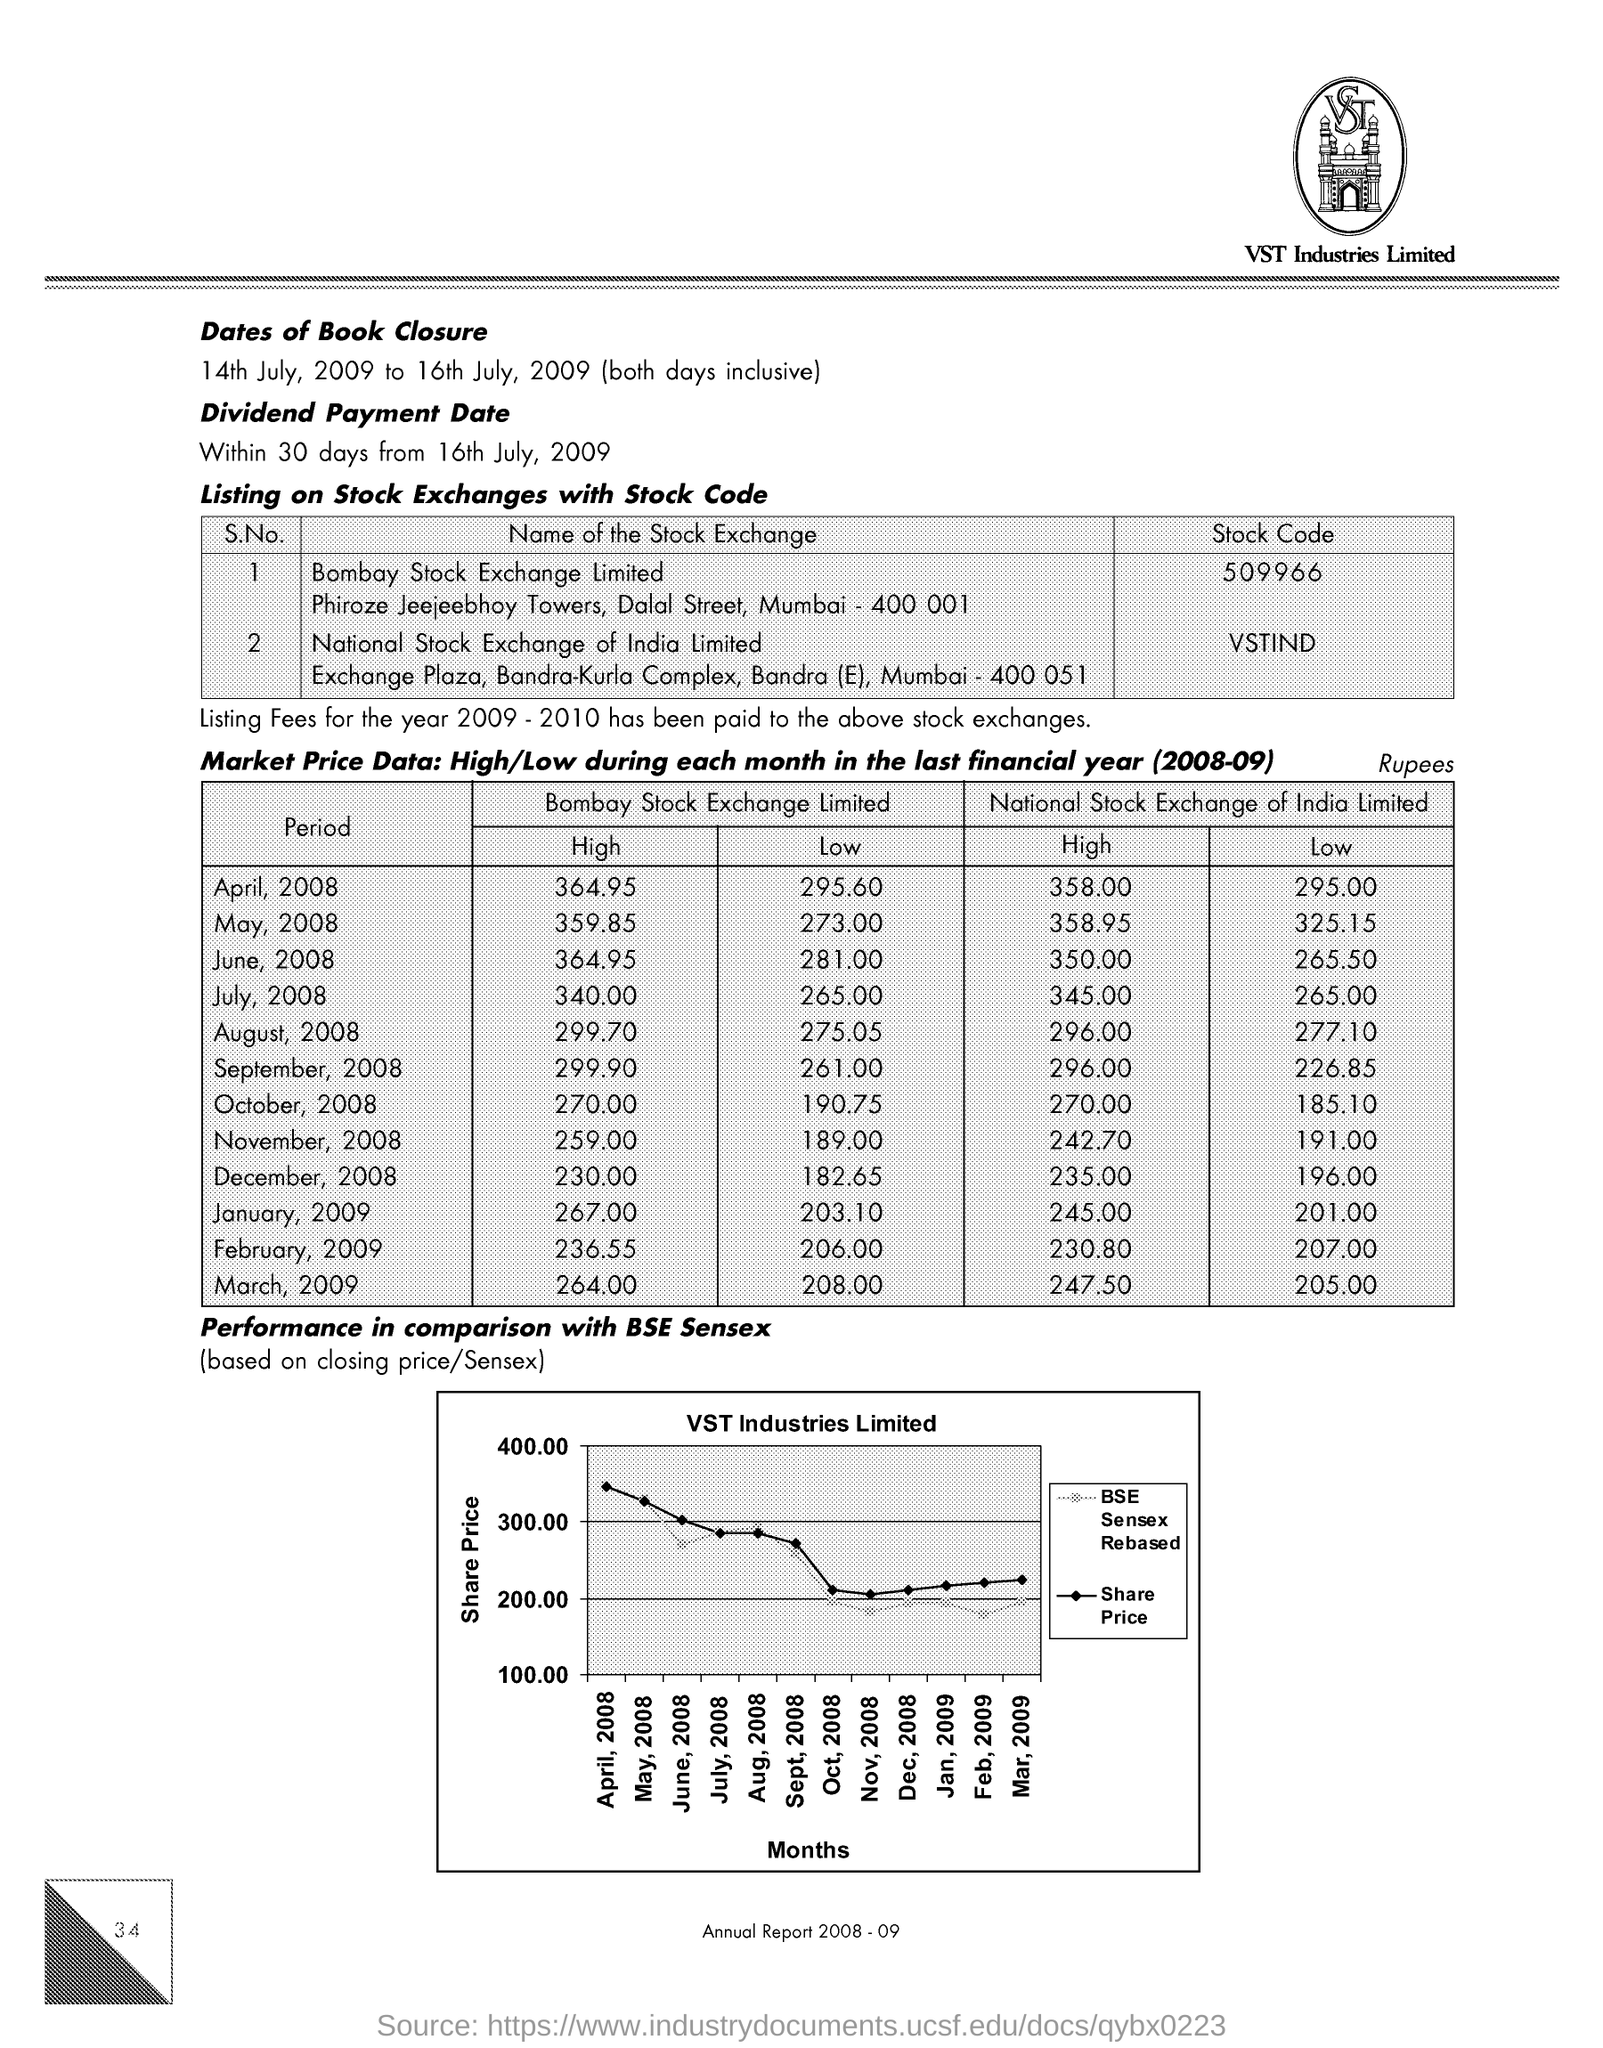List a handful of essential elements in this visual. On March 31st, 2009, the highest Market share price on Bombay Stock Exchange (BSE) for the financial year 2008-09 was 264.00 rupees. The Y-axis of the graph represents the share price in comparison with the BSE Sensex, which is the benchmark index for the Indian stock market. The stock code of company's shares listed on Bombay Stock Exchange Limited is 509966... The highest market share price on Bombay Stock Exchange in April 2008 for the financial year 2008-09 was 364.95 rupees. The X-axis of the graph represents the months in comparison with the BSE Sensex, which is a benchmark index in India. 